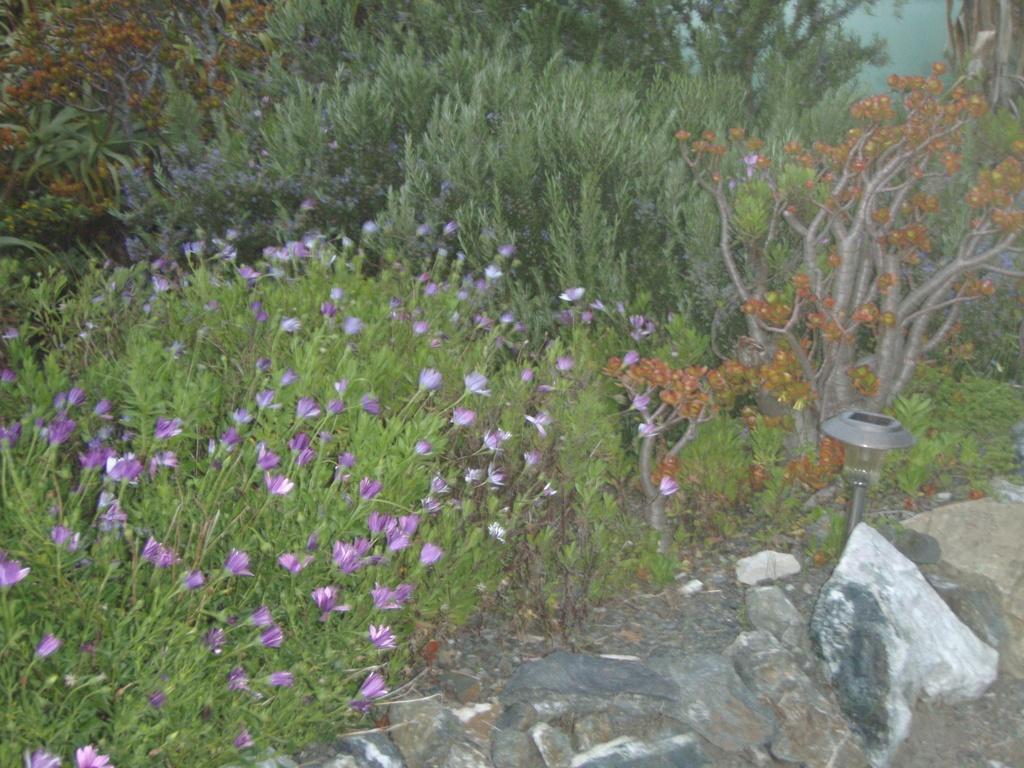Please provide a concise description of this image. This picture is clicked outside. In the foreground we can see the stones and an object placed on the ground. In the center we can see the plants and the flowers. In the background we can see the plants. 